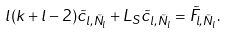Convert formula to latex. <formula><loc_0><loc_0><loc_500><loc_500>l ( k + l - 2 ) \tilde { c } _ { l , \tilde { N } _ { l } } + L _ { S } \tilde { c } _ { l , \tilde { N } _ { l } } = \tilde { F } _ { l , \tilde { N } _ { l } } .</formula> 